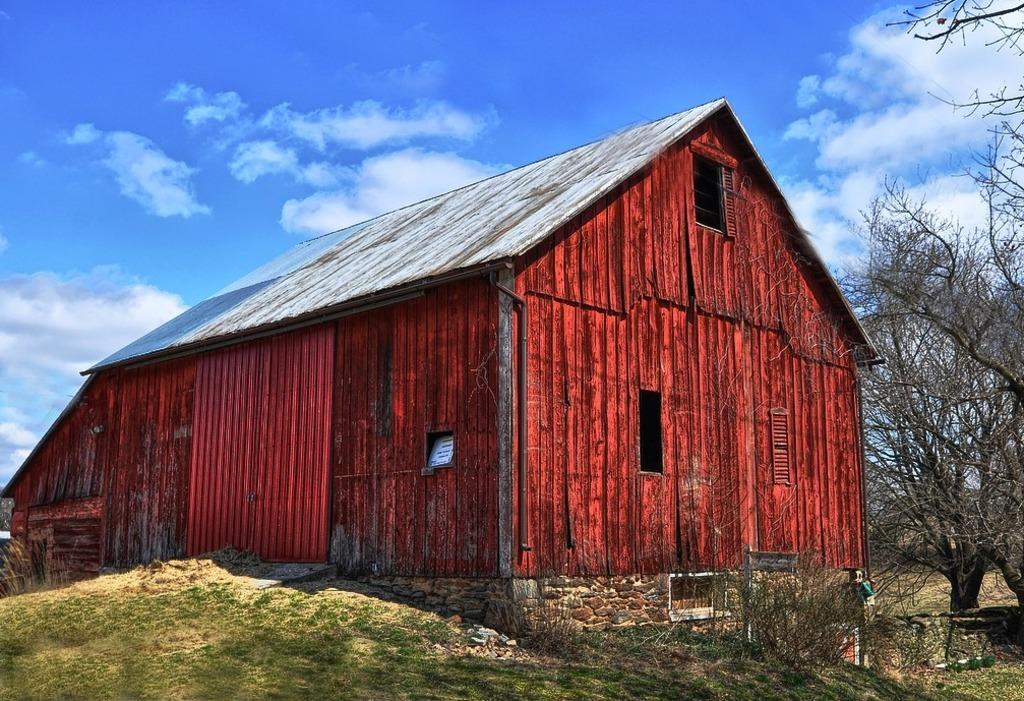What is the main structure in the center of the image? There is a house in the center of the image. What type of vegetation is present at the bottom of the image? There is grass and plants at the bottom of the image. What can be seen on the right side of the image? There are trees on the right side of the image. What is visible at the top of the image? The sky is visible at the top of the image. What type of collar is the squirrel wearing in the image? There is no squirrel present in the image, and therefore no collar can be observed. What fact can be learned about the house from the image? The fact that there is a house in the center of the image is already known from the provided facts; no additional fact can be learned from the image. 